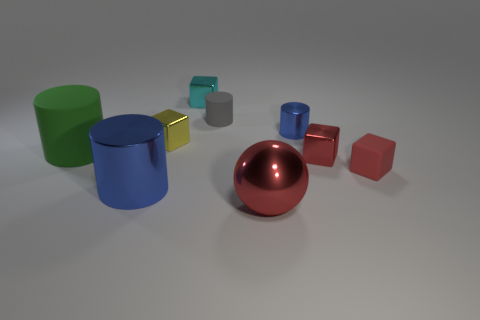Is the large shiny cylinder the same color as the tiny metal cylinder?
Make the answer very short. Yes. What number of metal objects are tiny blue objects or tiny red things?
Make the answer very short. 2. What color is the matte object that is both to the right of the tiny yellow thing and on the left side of the red rubber block?
Give a very brief answer. Gray. What number of red metal blocks are in front of the tiny cyan metal object?
Your answer should be very brief. 1. What material is the small gray object?
Your response must be concise. Rubber. There is a tiny rubber thing on the right side of the small cylinder that is on the right side of the red metal thing left of the small red shiny thing; what color is it?
Keep it short and to the point. Red. What number of green cubes have the same size as the yellow object?
Make the answer very short. 0. There is a cylinder in front of the big green cylinder; what color is it?
Your answer should be very brief. Blue. How many other objects are there of the same size as the gray matte cylinder?
Provide a short and direct response. 5. There is a rubber object that is on the right side of the green matte cylinder and in front of the yellow metallic object; what is its size?
Make the answer very short. Small. 